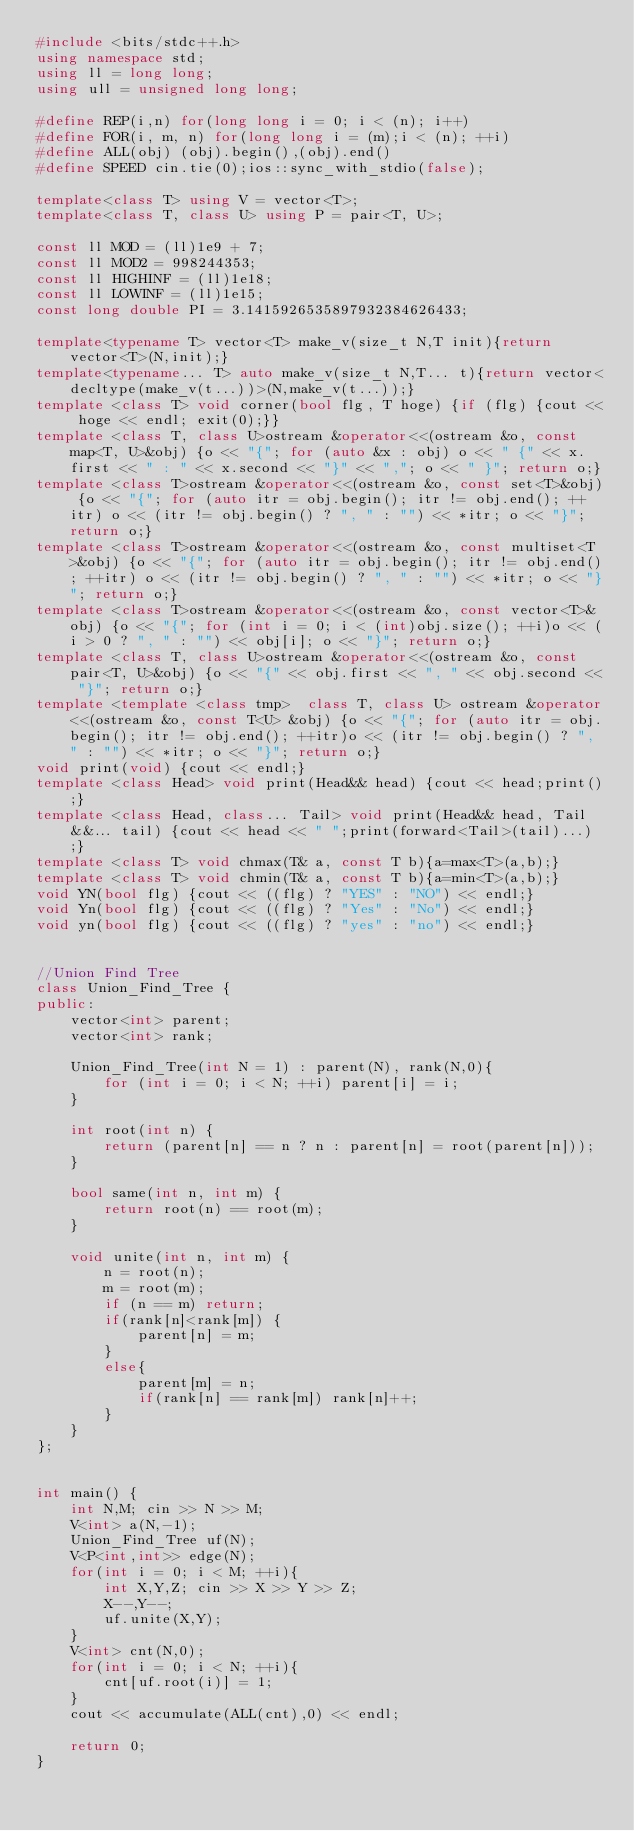<code> <loc_0><loc_0><loc_500><loc_500><_C++_>#include <bits/stdc++.h>
using namespace std;
using ll = long long;
using ull = unsigned long long;

#define REP(i,n) for(long long i = 0; i < (n); i++)
#define FOR(i, m, n) for(long long i = (m);i < (n); ++i)
#define ALL(obj) (obj).begin(),(obj).end()
#define SPEED cin.tie(0);ios::sync_with_stdio(false);

template<class T> using V = vector<T>;
template<class T, class U> using P = pair<T, U>;

const ll MOD = (ll)1e9 + 7;
const ll MOD2 = 998244353;
const ll HIGHINF = (ll)1e18;
const ll LOWINF = (ll)1e15;
const long double PI = 3.1415926535897932384626433;

template<typename T> vector<T> make_v(size_t N,T init){return vector<T>(N,init);}
template<typename... T> auto make_v(size_t N,T... t){return vector<decltype(make_v(t...))>(N,make_v(t...));}
template <class T> void corner(bool flg, T hoge) {if (flg) {cout << hoge << endl; exit(0);}}
template <class T, class U>ostream &operator<<(ostream &o, const map<T, U>&obj) {o << "{"; for (auto &x : obj) o << " {" << x.first << " : " << x.second << "}" << ","; o << " }"; return o;}
template <class T>ostream &operator<<(ostream &o, const set<T>&obj) {o << "{"; for (auto itr = obj.begin(); itr != obj.end(); ++itr) o << (itr != obj.begin() ? ", " : "") << *itr; o << "}"; return o;}
template <class T>ostream &operator<<(ostream &o, const multiset<T>&obj) {o << "{"; for (auto itr = obj.begin(); itr != obj.end(); ++itr) o << (itr != obj.begin() ? ", " : "") << *itr; o << "}"; return o;}
template <class T>ostream &operator<<(ostream &o, const vector<T>&obj) {o << "{"; for (int i = 0; i < (int)obj.size(); ++i)o << (i > 0 ? ", " : "") << obj[i]; o << "}"; return o;}
template <class T, class U>ostream &operator<<(ostream &o, const pair<T, U>&obj) {o << "{" << obj.first << ", " << obj.second << "}"; return o;}
template <template <class tmp>  class T, class U> ostream &operator<<(ostream &o, const T<U> &obj) {o << "{"; for (auto itr = obj.begin(); itr != obj.end(); ++itr)o << (itr != obj.begin() ? ", " : "") << *itr; o << "}"; return o;}
void print(void) {cout << endl;}
template <class Head> void print(Head&& head) {cout << head;print();}
template <class Head, class... Tail> void print(Head&& head, Tail&&... tail) {cout << head << " ";print(forward<Tail>(tail)...);}
template <class T> void chmax(T& a, const T b){a=max<T>(a,b);}
template <class T> void chmin(T& a, const T b){a=min<T>(a,b);}
void YN(bool flg) {cout << ((flg) ? "YES" : "NO") << endl;}
void Yn(bool flg) {cout << ((flg) ? "Yes" : "No") << endl;}
void yn(bool flg) {cout << ((flg) ? "yes" : "no") << endl;}


//Union Find Tree
class Union_Find_Tree {
public:
	vector<int> parent;
    vector<int> rank;

    Union_Find_Tree(int N = 1) : parent(N), rank(N,0){
		for (int i = 0; i < N; ++i) parent[i] = i;
	}
 
	int root(int n) {
		return (parent[n] == n ? n : parent[n] = root(parent[n]));
	}

    bool same(int n, int m) {
		return root(n) == root(m);
	}
 
	void unite(int n, int m) {
		n = root(n);
		m = root(m);
		if (n == m) return;
		if(rank[n]<rank[m]) {
            parent[n] = m;
        }
        else{
            parent[m] = n;
            if(rank[n] == rank[m]) rank[n]++;
        }
	}
};


int main() {
	int N,M; cin >> N >> M;
	V<int> a(N,-1);
	Union_Find_Tree uf(N);
	V<P<int,int>> edge(N);
	for(int i = 0; i < M; ++i){
		int X,Y,Z; cin >> X >> Y >> Z;
		X--,Y--;
		uf.unite(X,Y);
	}
	V<int> cnt(N,0);
	for(int i = 0; i < N; ++i){
		cnt[uf.root(i)] = 1;
	}
	cout << accumulate(ALL(cnt),0) << endl;
  
    return 0;
}
</code> 